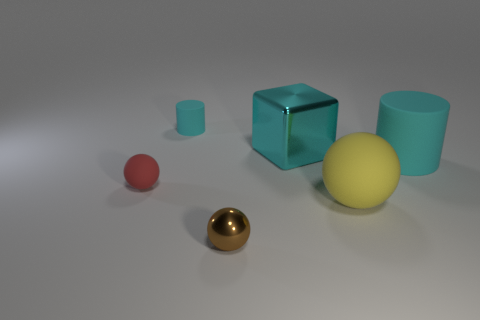Add 1 tiny red objects. How many objects exist? 7 Subtract all cylinders. How many objects are left? 4 Add 4 big metal things. How many big metal things are left? 5 Add 2 yellow rubber balls. How many yellow rubber balls exist? 3 Subtract 0 red cylinders. How many objects are left? 6 Subtract all large gray matte balls. Subtract all large objects. How many objects are left? 3 